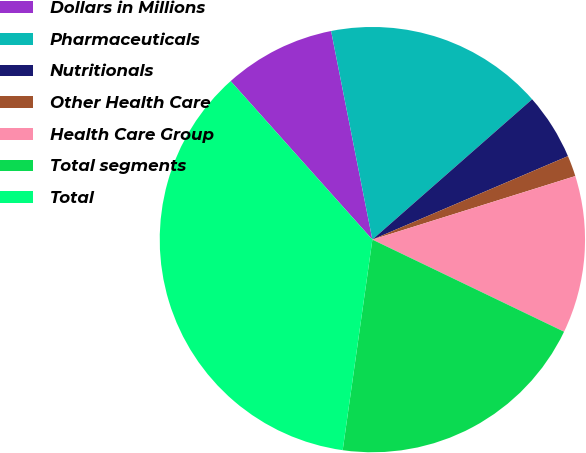Convert chart. <chart><loc_0><loc_0><loc_500><loc_500><pie_chart><fcel>Dollars in Millions<fcel>Pharmaceuticals<fcel>Nutritionals<fcel>Other Health Care<fcel>Health Care Group<fcel>Total segments<fcel>Total<nl><fcel>8.5%<fcel>16.64%<fcel>5.05%<fcel>1.59%<fcel>11.96%<fcel>20.1%<fcel>36.16%<nl></chart> 